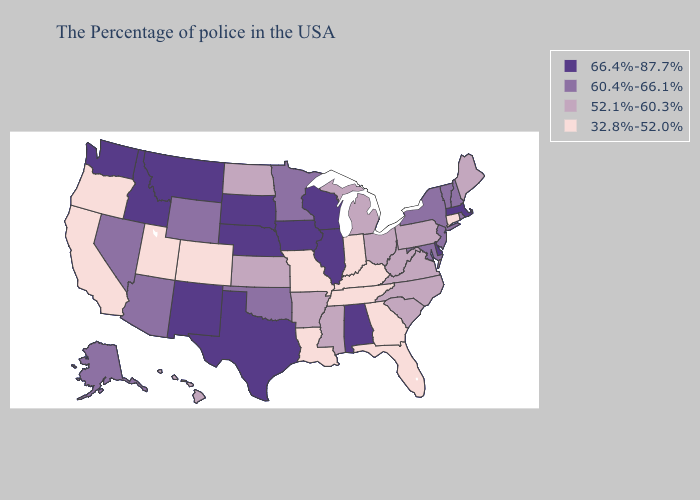Does the map have missing data?
Write a very short answer. No. What is the lowest value in states that border Idaho?
Short answer required. 32.8%-52.0%. Does Alabama have the lowest value in the South?
Concise answer only. No. What is the value of Kentucky?
Concise answer only. 32.8%-52.0%. What is the value of Connecticut?
Give a very brief answer. 32.8%-52.0%. How many symbols are there in the legend?
Be succinct. 4. What is the lowest value in states that border Pennsylvania?
Quick response, please. 52.1%-60.3%. Name the states that have a value in the range 52.1%-60.3%?
Keep it brief. Maine, Pennsylvania, Virginia, North Carolina, South Carolina, West Virginia, Ohio, Michigan, Mississippi, Arkansas, Kansas, North Dakota, Hawaii. Among the states that border Massachusetts , which have the lowest value?
Keep it brief. Connecticut. What is the highest value in states that border North Carolina?
Give a very brief answer. 52.1%-60.3%. Which states have the highest value in the USA?
Write a very short answer. Massachusetts, Delaware, Alabama, Wisconsin, Illinois, Iowa, Nebraska, Texas, South Dakota, New Mexico, Montana, Idaho, Washington. Does Colorado have the lowest value in the USA?
Short answer required. Yes. What is the value of Texas?
Write a very short answer. 66.4%-87.7%. Among the states that border Oregon , which have the lowest value?
Give a very brief answer. California. 